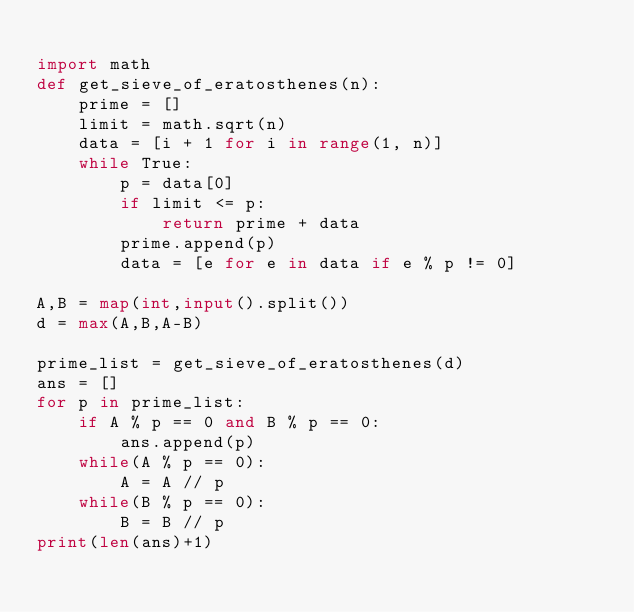Convert code to text. <code><loc_0><loc_0><loc_500><loc_500><_Python_>
import math
def get_sieve_of_eratosthenes(n):
    prime = []
    limit = math.sqrt(n)
    data = [i + 1 for i in range(1, n)]
    while True:
        p = data[0]
        if limit <= p:
            return prime + data
        prime.append(p)
        data = [e for e in data if e % p != 0]

A,B = map(int,input().split())
d = max(A,B,A-B)

prime_list = get_sieve_of_eratosthenes(d)
ans = []
for p in prime_list:
    if A % p == 0 and B % p == 0:
        ans.append(p)
    while(A % p == 0):
        A = A // p
    while(B % p == 0):
        B = B // p
print(len(ans)+1)
 </code> 